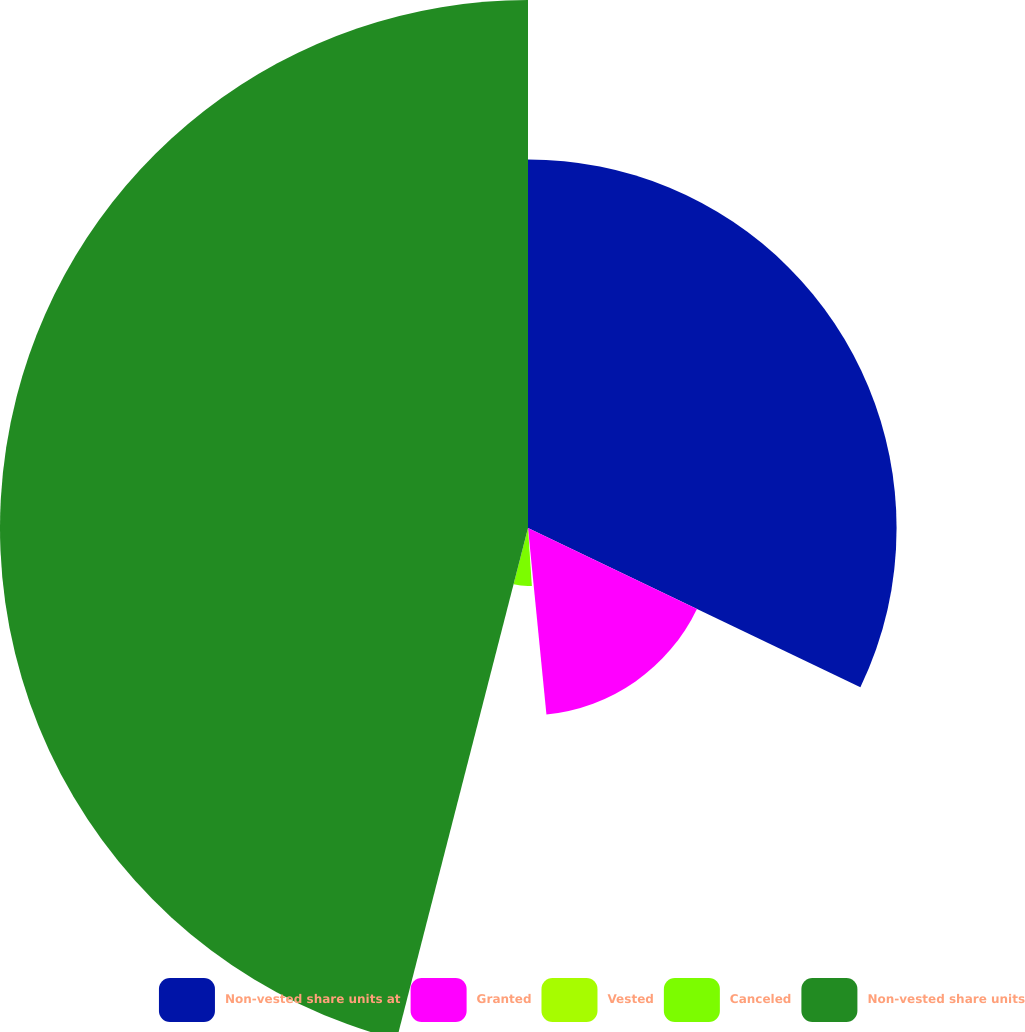Convert chart. <chart><loc_0><loc_0><loc_500><loc_500><pie_chart><fcel>Non-vested share units at<fcel>Granted<fcel>Vested<fcel>Canceled<fcel>Non-vested share units<nl><fcel>32.11%<fcel>16.32%<fcel>0.51%<fcel>5.06%<fcel>46.0%<nl></chart> 